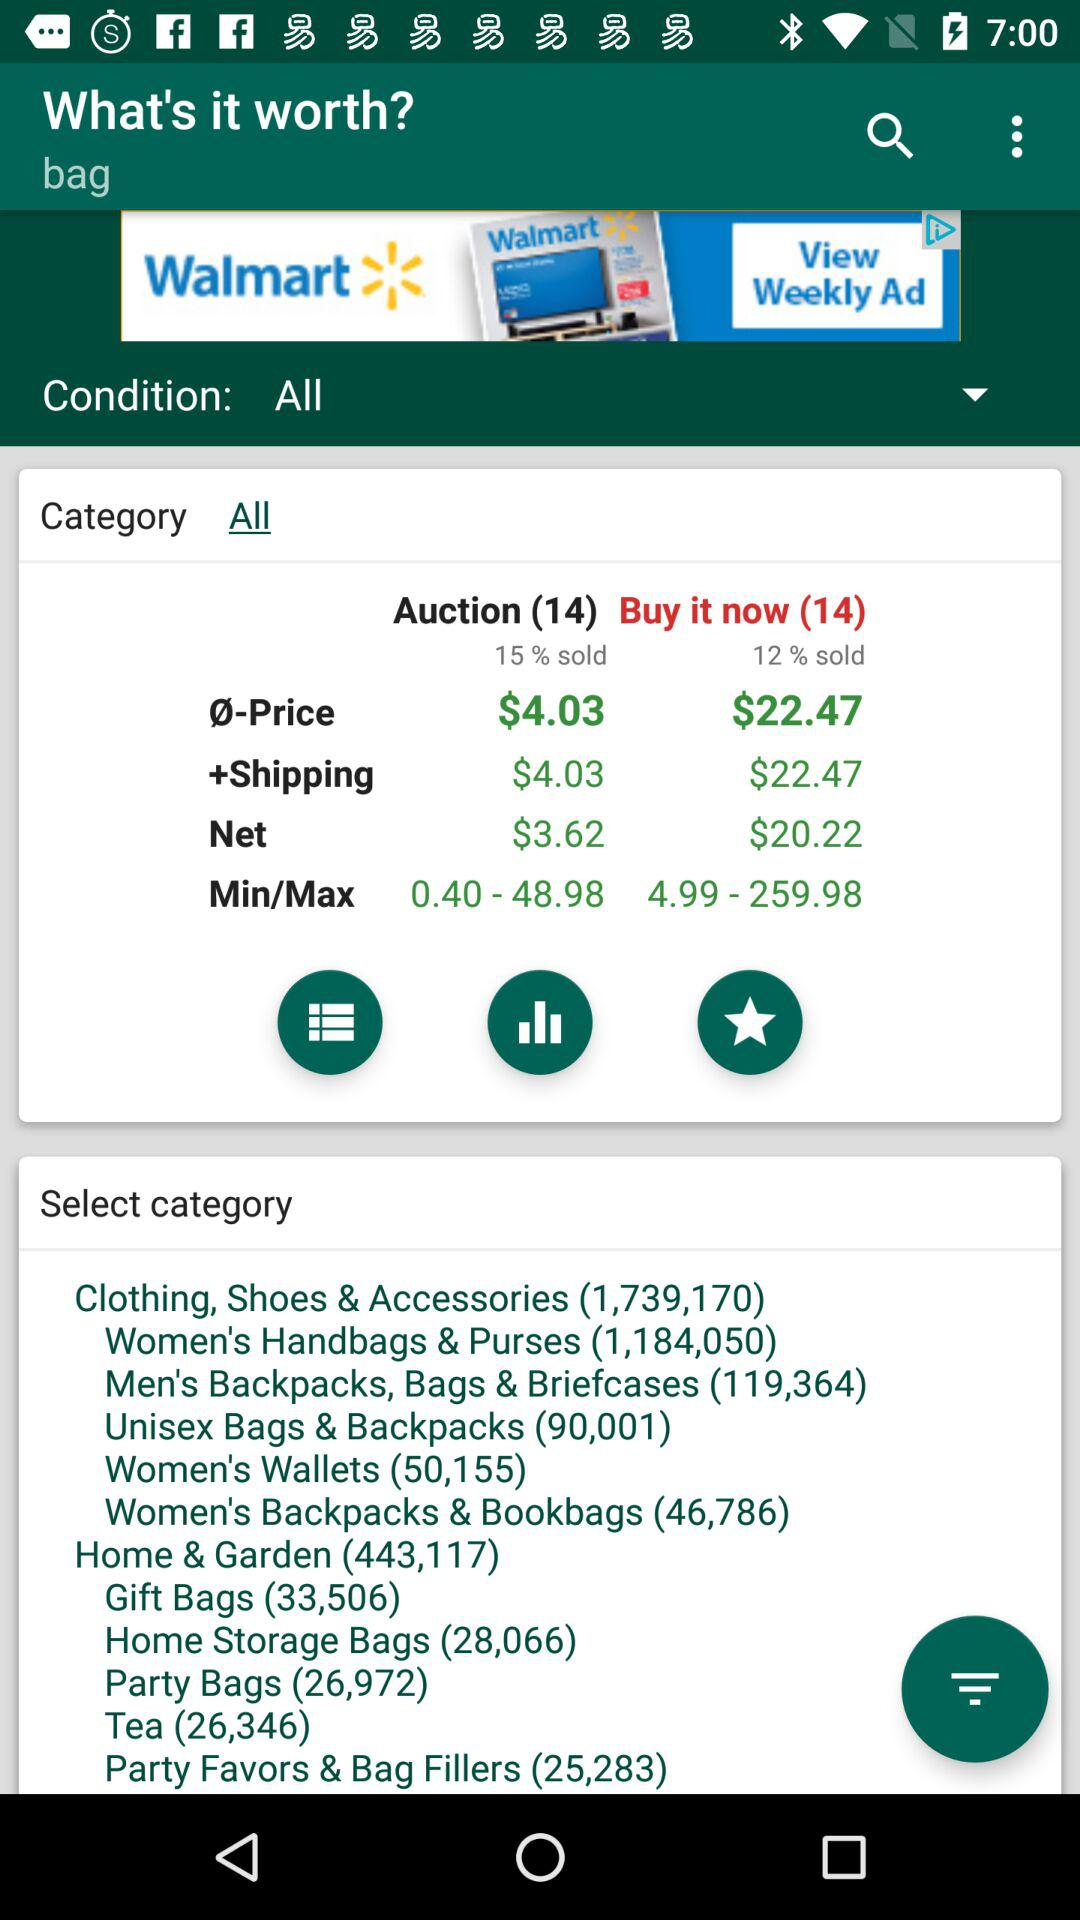What is the shipping price for the auction? The shipping price for the auction is $4.03. 